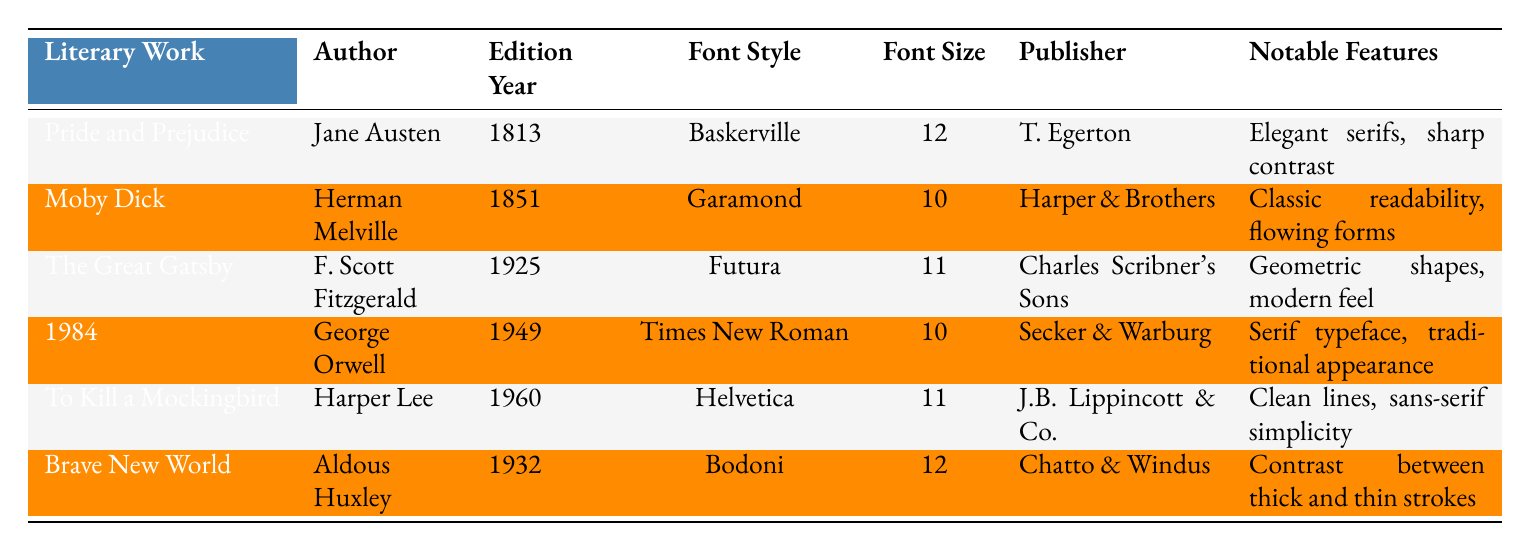What is the font style used in "The Great Gatsby"? In the table, under the "Literary Work" column, I locate "The Great Gatsby" and find the corresponding "Font Style" listed in the same row, which is Futura.
Answer: Futura Which literary work was published in 1813? I look in the "Edition Year" column and find 1813, then check the corresponding "Literary Work" in that row which shows Pride and Prejudice.
Answer: Pride and Prejudice How many works utilize a font size of 11? I count the entries in the "Font Size" column that list 11. The entries are for "The Great Gatsby" and "To Kill a Mockingbird", making a total of 2 works.
Answer: 2 Is "Garamond" the font style for any book by a modern author? I check the authors listed alongside the font style "Garamond". The author is Herman Melville, who published Moby Dick in 1851, which isn't considered modern. Therefore, the answer is no.
Answer: No Which publisher released "1984" and what is its notable feature? I find "1984" in the "Literary Work" column, and check the associated "Publisher" and "Notable Features" fields, which reveal that it was published by Secker & Warburg and the notable feature is a serif typeface with a traditional appearance.
Answer: Secker & Warburg, serif typeface, traditional appearance What is the average font size of the works listed? I first total the font sizes: 12 (Pride and Prejudice) + 10 (Moby Dick) + 11 (The Great Gatsby) + 10 (1984) + 11 (To Kill a Mockingbird) + 12 (Brave New World) = 64. Next, there are 6 works, so I calculate the average as 64 divided by 6, which gives approximately 10.67.
Answer: 10.67 Which author has the highest noted typography style score regarding aesthetics? Looking through the notable features and assessing aesthetic qualities, I deduce that Aldous Huxley's "Brave New World" with Bodoni displays the highest aesthetic quality due to its contrast between thick and thin strokes as it offers a sophisticated visual style.
Answer: Aldous Huxley What is the notable feature of the font used in "To Kill a Mockingbird"? I can identify "To Kill a Mockingbird" in the table and refer to the "Notable Features" cell which states that the font features clean lines and sans-serif simplicity.
Answer: Clean lines, sans-serif simplicity Which work has the most modern font style? I analyze the "Font Style" column and see that "Futura," used in "The Great Gatsby," is recognized as a modern font compared to the others listed in the table.
Answer: The Great Gatsby 